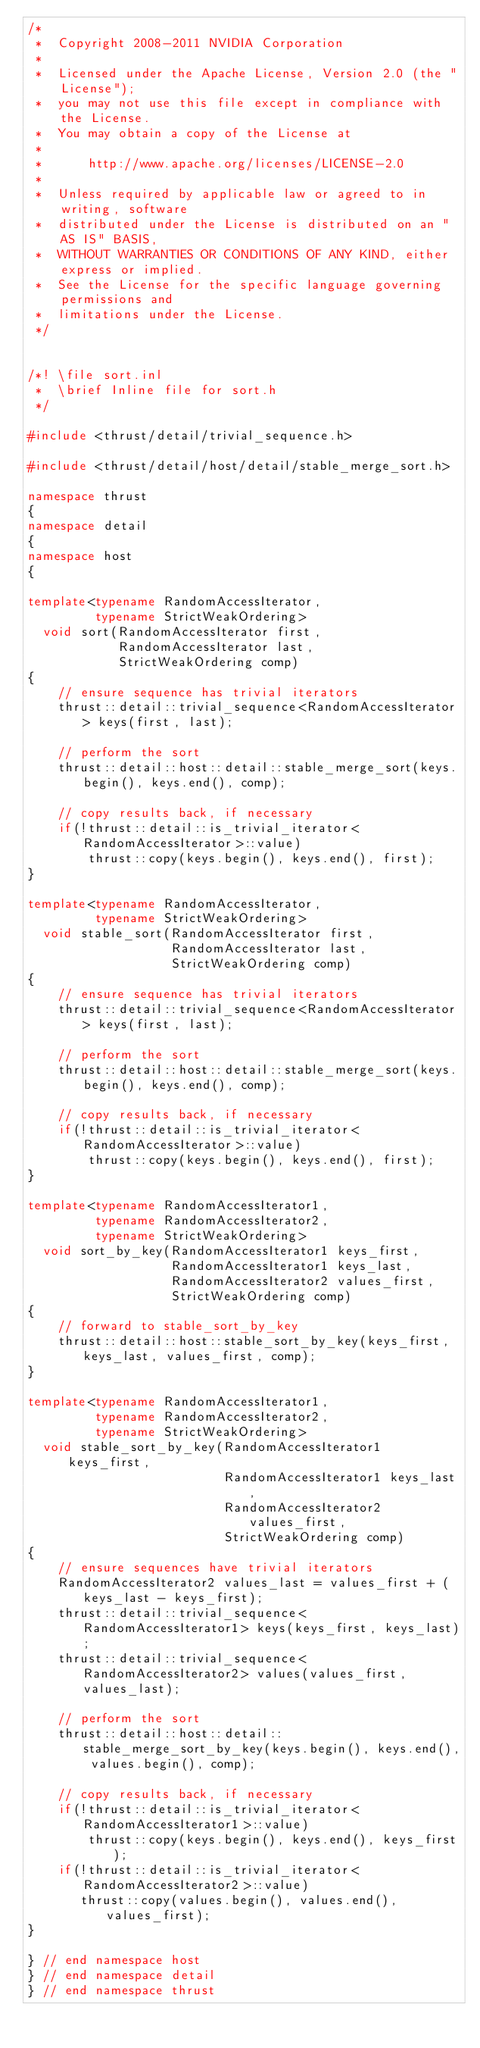Convert code to text. <code><loc_0><loc_0><loc_500><loc_500><_C++_>/*
 *  Copyright 2008-2011 NVIDIA Corporation
 *
 *  Licensed under the Apache License, Version 2.0 (the "License");
 *  you may not use this file except in compliance with the License.
 *  You may obtain a copy of the License at
 *
 *      http://www.apache.org/licenses/LICENSE-2.0
 *
 *  Unless required by applicable law or agreed to in writing, software
 *  distributed under the License is distributed on an "AS IS" BASIS,
 *  WITHOUT WARRANTIES OR CONDITIONS OF ANY KIND, either express or implied.
 *  See the License for the specific language governing permissions and
 *  limitations under the License.
 */


/*! \file sort.inl
 *  \brief Inline file for sort.h
 */

#include <thrust/detail/trivial_sequence.h>

#include <thrust/detail/host/detail/stable_merge_sort.h>

namespace thrust
{
namespace detail
{
namespace host
{

template<typename RandomAccessIterator,
         typename StrictWeakOrdering>
  void sort(RandomAccessIterator first,
            RandomAccessIterator last,
            StrictWeakOrdering comp)
{
    // ensure sequence has trivial iterators
    thrust::detail::trivial_sequence<RandomAccessIterator> keys(first, last);
 
    // perform the sort
    thrust::detail::host::detail::stable_merge_sort(keys.begin(), keys.end(), comp);
  
    // copy results back, if necessary
    if(!thrust::detail::is_trivial_iterator<RandomAccessIterator>::value)
        thrust::copy(keys.begin(), keys.end(), first);
}

template<typename RandomAccessIterator,
         typename StrictWeakOrdering>
  void stable_sort(RandomAccessIterator first,
                   RandomAccessIterator last,
                   StrictWeakOrdering comp)
{
    // ensure sequence has trivial iterators
    thrust::detail::trivial_sequence<RandomAccessIterator> keys(first, last);

    // perform the sort
    thrust::detail::host::detail::stable_merge_sort(keys.begin(), keys.end(), comp);
  
    // copy results back, if necessary
    if(!thrust::detail::is_trivial_iterator<RandomAccessIterator>::value)
        thrust::copy(keys.begin(), keys.end(), first);
}

template<typename RandomAccessIterator1,
         typename RandomAccessIterator2,
         typename StrictWeakOrdering>
  void sort_by_key(RandomAccessIterator1 keys_first,
                   RandomAccessIterator1 keys_last,
                   RandomAccessIterator2 values_first,
                   StrictWeakOrdering comp)
{
    // forward to stable_sort_by_key
    thrust::detail::host::stable_sort_by_key(keys_first, keys_last, values_first, comp);
}

template<typename RandomAccessIterator1,
         typename RandomAccessIterator2,
         typename StrictWeakOrdering>
  void stable_sort_by_key(RandomAccessIterator1 keys_first,
                          RandomAccessIterator1 keys_last,
                          RandomAccessIterator2 values_first,
                          StrictWeakOrdering comp)
{
    // ensure sequences have trivial iterators
    RandomAccessIterator2 values_last = values_first + (keys_last - keys_first);
    thrust::detail::trivial_sequence<RandomAccessIterator1> keys(keys_first, keys_last);
    thrust::detail::trivial_sequence<RandomAccessIterator2> values(values_first, values_last);

    // perform the sort
    thrust::detail::host::detail::stable_merge_sort_by_key(keys.begin(), keys.end(), values.begin(), comp);

    // copy results back, if necessary
    if(!thrust::detail::is_trivial_iterator<RandomAccessIterator1>::value)
        thrust::copy(keys.begin(), keys.end(), keys_first);
    if(!thrust::detail::is_trivial_iterator<RandomAccessIterator2>::value)
       thrust::copy(values.begin(), values.end(), values_first);
}

} // end namespace host
} // end namespace detail
} // end namespace thrust

</code> 